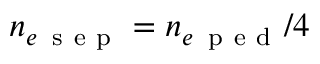<formula> <loc_0><loc_0><loc_500><loc_500>n _ { e \, s e p } = n _ { e \, p e d } / 4</formula> 